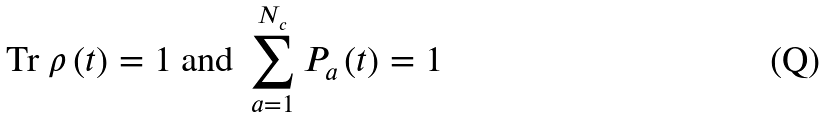Convert formula to latex. <formula><loc_0><loc_0><loc_500><loc_500>\text {Tr } \rho \left ( t \right ) = 1 \text { and } \sum _ { a = 1 } ^ { N _ { c } } P _ { a } \left ( t \right ) = 1</formula> 